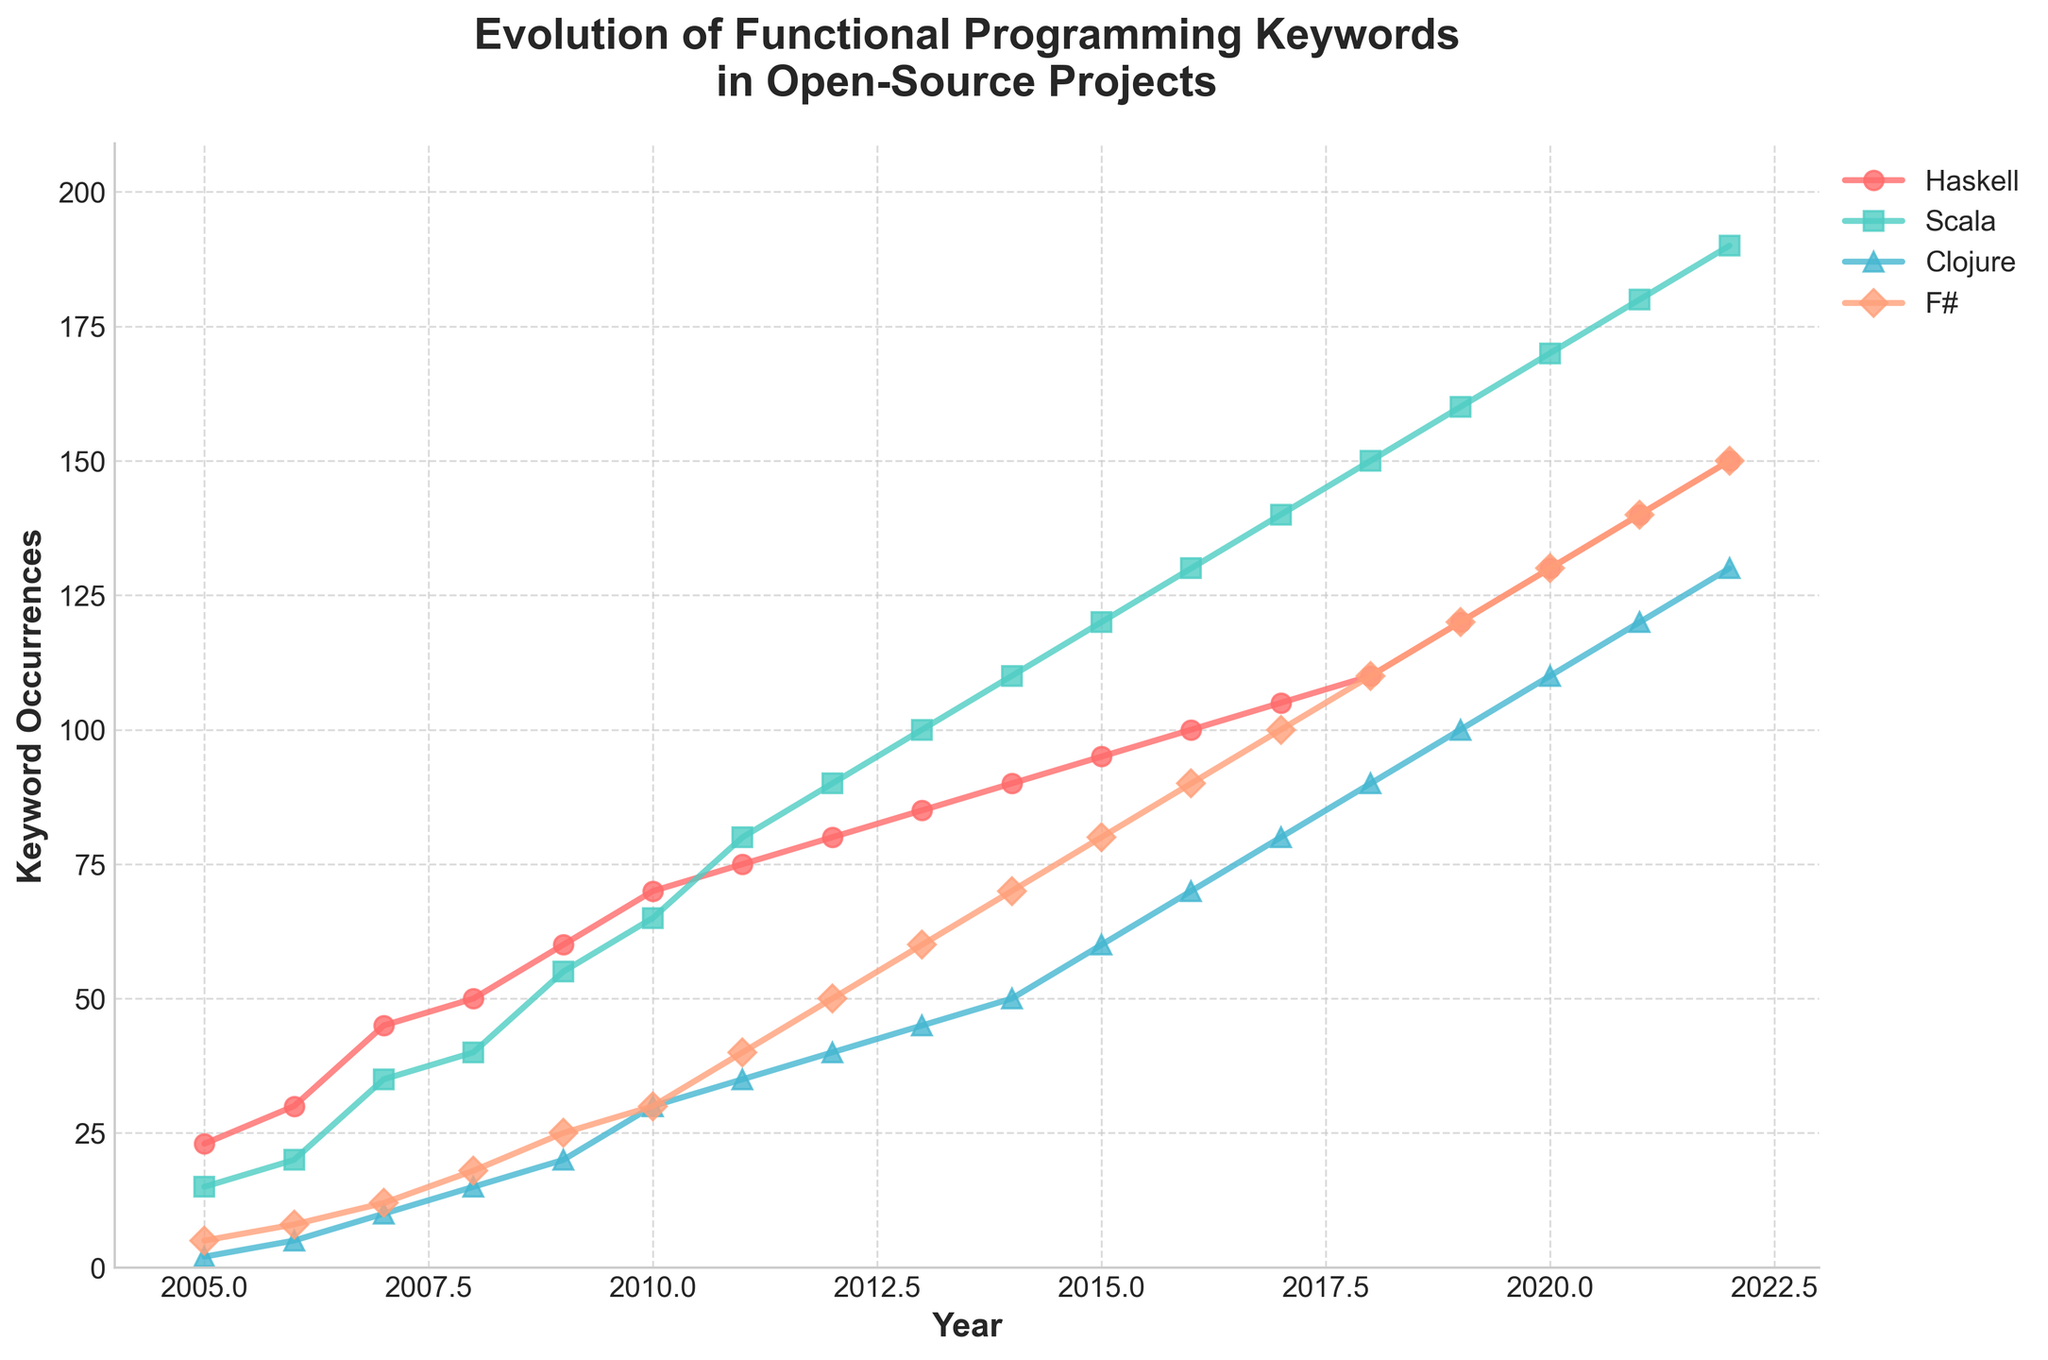What is the title of the plot? The title of the plot is written at the top of the figure in a larger and bold font. It reads "Evolution of Functional Programming Keywords in Open-Source Projects."
Answer: Evolution of Functional Programming Keywords in Open-Source Projects Which year had the highest keyword occurrences for Haskell? To find the highest keyword occurrences for Haskell, look for the peak value on the Haskell curve (red line with circle markers). This peak value occurs at the far-right end of the timeline in 2022.
Answer: 2022 How many years are displayed on the x-axis? The x-axis represents the years from 2005 to 2022. Count the number of tick marks starting from 2005 and ending at 2022.
Answer: 18 years What is the overall trend for Scala from 2005 to 2022? Observe the Scala line (cyan line with square markers). From 2005 to 2022, the number of occurrences shows a consistently increasing trend.
Answer: Increasing In which year did Clojure surpass 50 keyword occurrences? Identify the point on the Clojure line (purple line with triangle markers) where the keyword occurrences first exceed 50. This happens in 2014.
Answer: 2014 Compare the keyword occurrences for F# and Scala in 2011. Which one is higher? Locate the values for F# (orange line with diamond markers) and Scala (cyan line with square markers) in the year 2011. F# has an occurrence of 40, while Scala has 80.
Answer: Scala What is the difference in keyword occurrences between Haskell and F# in 2022? Check the value of keyword occurrences for Haskell and F# in the year 2022. Haskell has 150 occurrences, and F# has 150. The difference is 150 - 150.
Answer: 0 Between which consecutive years did Haskell see the largest increase in keyword occurrences? By examining the Haskell line, calculate the differences in keyword occurrences between each consecutive year. The largest increase is from 2021 (140) to 2022 (150), an increase of 10.
Answer: 2021 to 2022 What is the average number of keyword occurrences for Clojure over the years 2010 to 2019? Sum the keyword occurrences for Clojure from 2010 to 2019 and divide by the number of years. The sum is 30 + 35 + 40 + 45 + 50 + 60 + 70 + 80 + 90 + 100 = 600. There are 10 years, so 600 / 10 = 60.
Answer: 60 